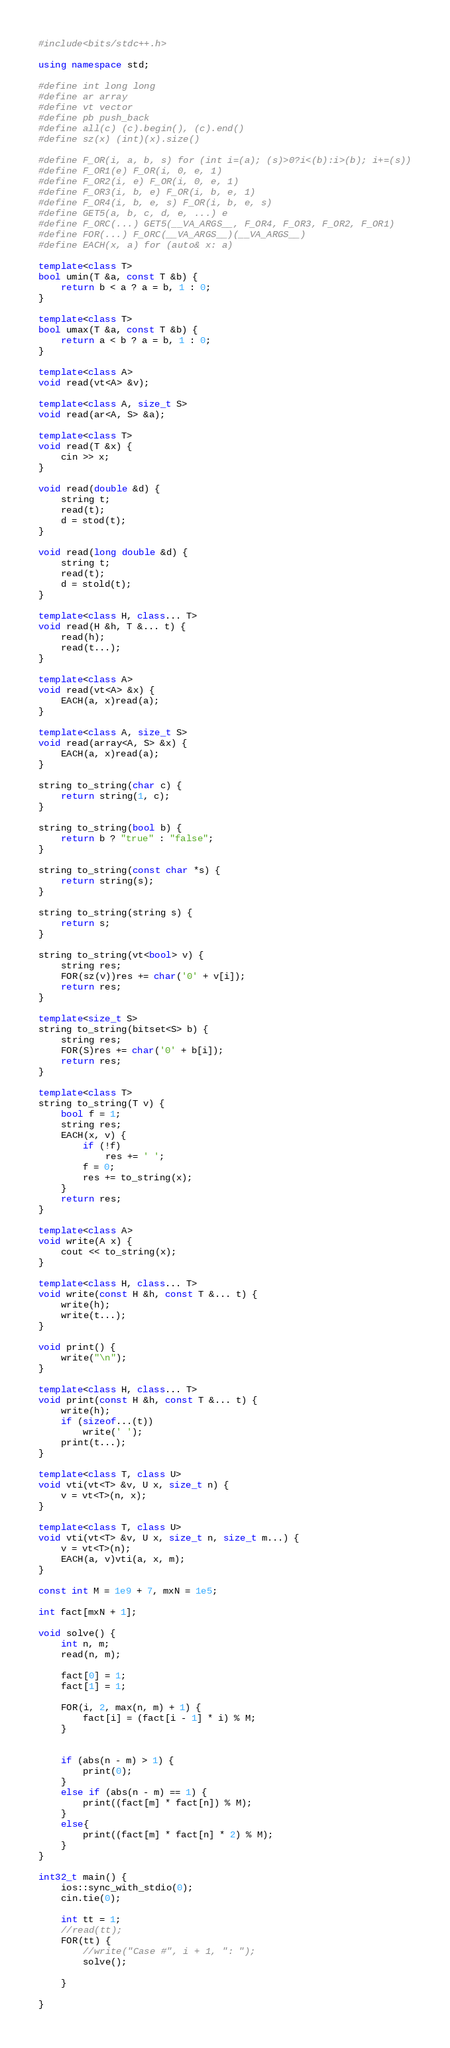<code> <loc_0><loc_0><loc_500><loc_500><_C++_>#include<bits/stdc++.h>

using namespace std;

#define int long long
#define ar array
#define vt vector
#define pb push_back
#define all(c) (c).begin(), (c).end()
#define sz(x) (int)(x).size()

#define F_OR(i, a, b, s) for (int i=(a); (s)>0?i<(b):i>(b); i+=(s))
#define F_OR1(e) F_OR(i, 0, e, 1)
#define F_OR2(i, e) F_OR(i, 0, e, 1)
#define F_OR3(i, b, e) F_OR(i, b, e, 1)
#define F_OR4(i, b, e, s) F_OR(i, b, e, s)
#define GET5(a, b, c, d, e, ...) e
#define F_ORC(...) GET5(__VA_ARGS__, F_OR4, F_OR3, F_OR2, F_OR1)
#define FOR(...) F_ORC(__VA_ARGS__)(__VA_ARGS__)
#define EACH(x, a) for (auto& x: a)

template<class T>
bool umin(T &a, const T &b) {
    return b < a ? a = b, 1 : 0;
}

template<class T>
bool umax(T &a, const T &b) {
    return a < b ? a = b, 1 : 0;
}

template<class A>
void read(vt<A> &v);

template<class A, size_t S>
void read(ar<A, S> &a);

template<class T>
void read(T &x) {
    cin >> x;
}

void read(double &d) {
    string t;
    read(t);
    d = stod(t);
}

void read(long double &d) {
    string t;
    read(t);
    d = stold(t);
}

template<class H, class... T>
void read(H &h, T &... t) {
    read(h);
    read(t...);
}

template<class A>
void read(vt<A> &x) {
    EACH(a, x)read(a);
}

template<class A, size_t S>
void read(array<A, S> &x) {
    EACH(a, x)read(a);
}

string to_string(char c) {
    return string(1, c);
}

string to_string(bool b) {
    return b ? "true" : "false";
}

string to_string(const char *s) {
    return string(s);
}

string to_string(string s) {
    return s;
}

string to_string(vt<bool> v) {
    string res;
    FOR(sz(v))res += char('0' + v[i]);
    return res;
}

template<size_t S>
string to_string(bitset<S> b) {
    string res;
    FOR(S)res += char('0' + b[i]);
    return res;
}

template<class T>
string to_string(T v) {
    bool f = 1;
    string res;
    EACH(x, v) {
        if (!f)
            res += ' ';
        f = 0;
        res += to_string(x);
    }
    return res;
}

template<class A>
void write(A x) {
    cout << to_string(x);
}

template<class H, class... T>
void write(const H &h, const T &... t) {
    write(h);
    write(t...);
}

void print() {
    write("\n");
}

template<class H, class... T>
void print(const H &h, const T &... t) {
    write(h);
    if (sizeof...(t))
        write(' ');
    print(t...);
}

template<class T, class U>
void vti(vt<T> &v, U x, size_t n) {
    v = vt<T>(n, x);
}

template<class T, class U>
void vti(vt<T> &v, U x, size_t n, size_t m...) {
    v = vt<T>(n);
    EACH(a, v)vti(a, x, m);
}

const int M = 1e9 + 7, mxN = 1e5;

int fact[mxN + 1];

void solve() {
    int n, m;
    read(n, m);
    
    fact[0] = 1;
    fact[1] = 1;
    
    FOR(i, 2, max(n, m) + 1) {
        fact[i] = (fact[i - 1] * i) % M;
    }
    
    
    if (abs(n - m) > 1) {
        print(0);
    }
    else if (abs(n - m) == 1) {
        print((fact[m] * fact[n]) % M);
    }
    else{
        print((fact[m] * fact[n] * 2) % M);
    }
}

int32_t main() {
    ios::sync_with_stdio(0);
    cin.tie(0);
    
    int tt = 1;
    //read(tt);
    FOR(tt) {
        //write("Case #", i + 1, ": ");
        solve();
        
    }
    
}

</code> 